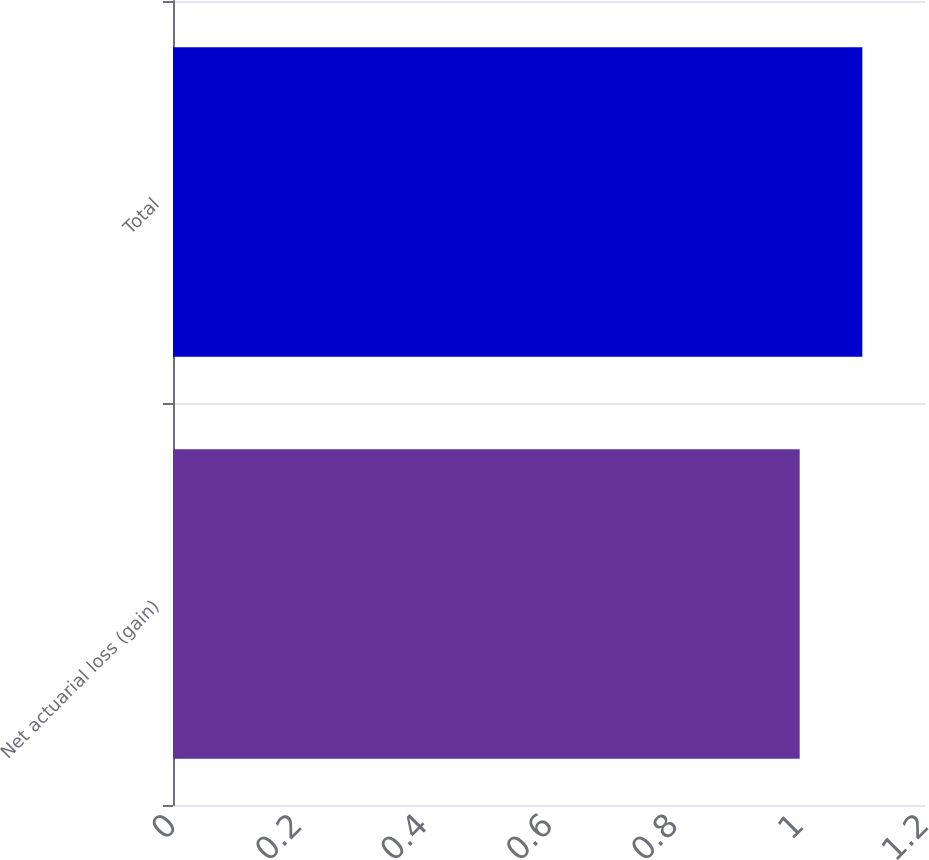Convert chart. <chart><loc_0><loc_0><loc_500><loc_500><bar_chart><fcel>Net actuarial loss (gain)<fcel>Total<nl><fcel>1<fcel>1.1<nl></chart> 